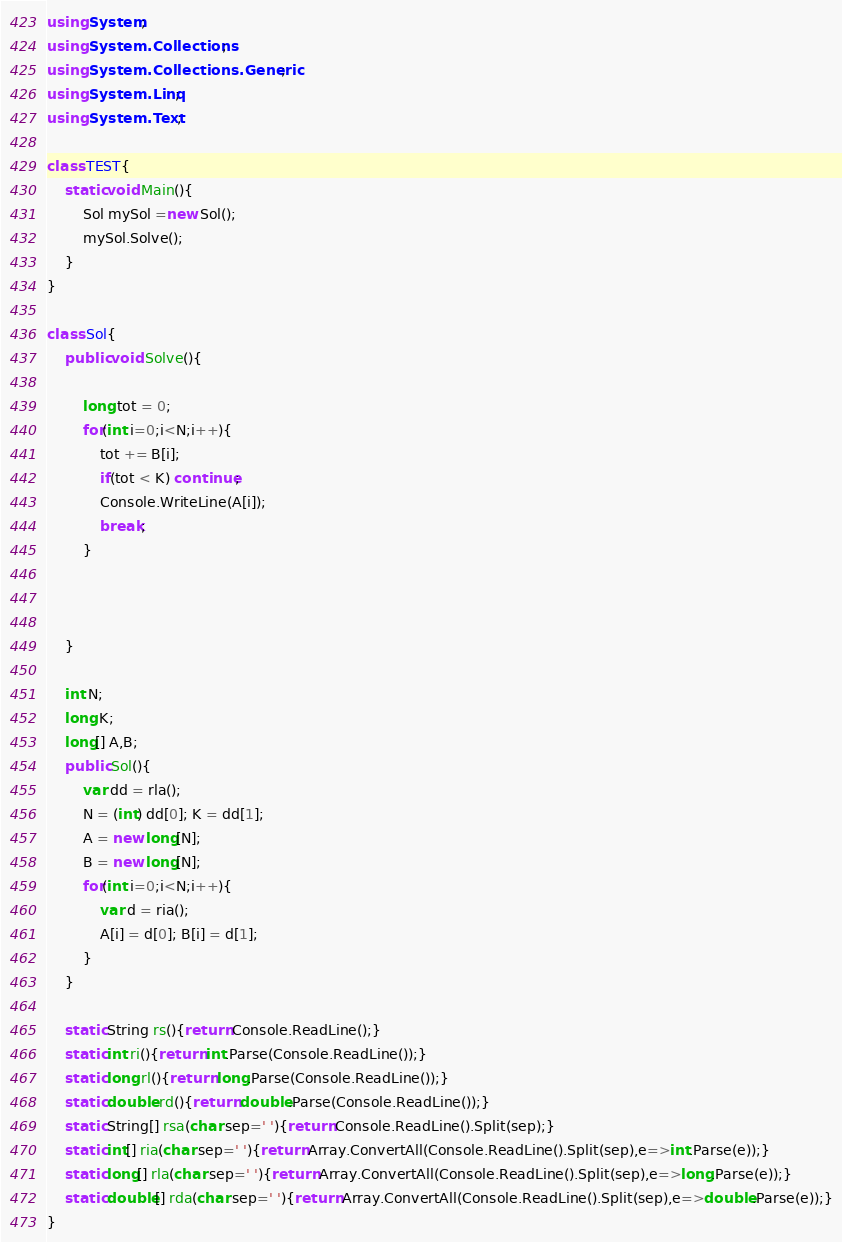<code> <loc_0><loc_0><loc_500><loc_500><_C#_>using System;
using System.Collections;
using System.Collections.Generic;
using System.Linq;
using System.Text;

class TEST{
	static void Main(){
		Sol mySol =new Sol();
		mySol.Solve();
	}
}

class Sol{
	public void Solve(){
		
		long tot = 0;
		for(int i=0;i<N;i++){
			tot += B[i];
			if(tot < K) continue;
			Console.WriteLine(A[i]);
			break;
		}
		
		
		
	}
	
	int N;
	long K;
	long[] A,B;
	public Sol(){
		var dd = rla();
		N = (int) dd[0]; K = dd[1];
		A = new long[N];
		B = new long[N];
		for(int i=0;i<N;i++){
			var d = ria();
			A[i] = d[0]; B[i] = d[1];
		}
	}

	static String rs(){return Console.ReadLine();}
	static int ri(){return int.Parse(Console.ReadLine());}
	static long rl(){return long.Parse(Console.ReadLine());}
	static double rd(){return double.Parse(Console.ReadLine());}
	static String[] rsa(char sep=' '){return Console.ReadLine().Split(sep);}
	static int[] ria(char sep=' '){return Array.ConvertAll(Console.ReadLine().Split(sep),e=>int.Parse(e));}
	static long[] rla(char sep=' '){return Array.ConvertAll(Console.ReadLine().Split(sep),e=>long.Parse(e));}
	static double[] rda(char sep=' '){return Array.ConvertAll(Console.ReadLine().Split(sep),e=>double.Parse(e));}
}
</code> 